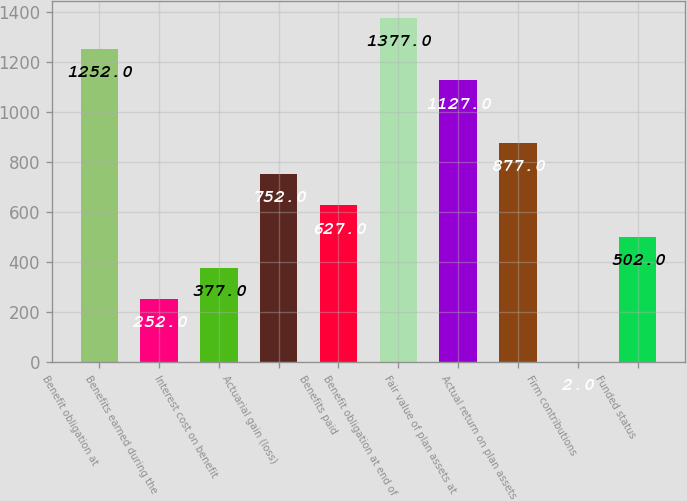Convert chart. <chart><loc_0><loc_0><loc_500><loc_500><bar_chart><fcel>Benefit obligation at<fcel>Benefits earned during the<fcel>Interest cost on benefit<fcel>Actuarial gain (loss)<fcel>Benefits paid<fcel>Benefit obligation at end of<fcel>Fair value of plan assets at<fcel>Actual return on plan assets<fcel>Firm contributions<fcel>Funded status<nl><fcel>1252<fcel>252<fcel>377<fcel>752<fcel>627<fcel>1377<fcel>1127<fcel>877<fcel>2<fcel>502<nl></chart> 